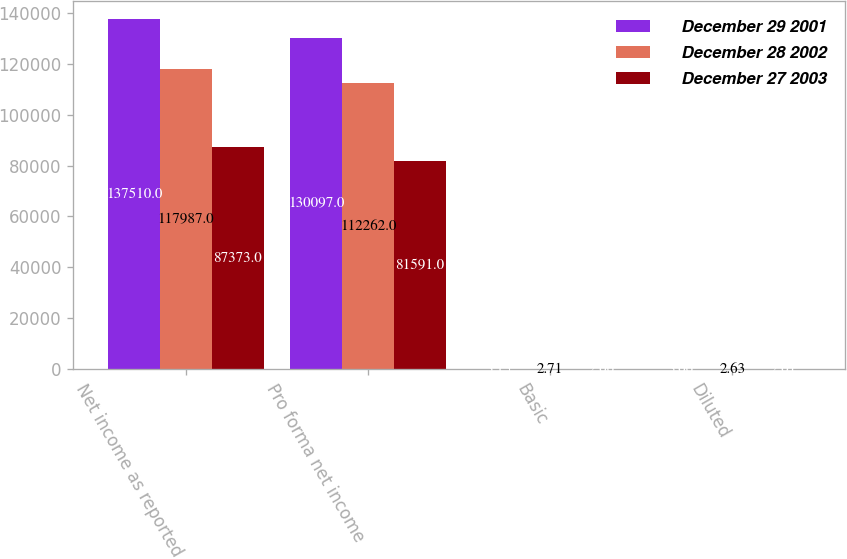Convert chart. <chart><loc_0><loc_0><loc_500><loc_500><stacked_bar_chart><ecel><fcel>Net income as reported<fcel>Pro forma net income<fcel>Basic<fcel>Diluted<nl><fcel>December 29 2001<fcel>137510<fcel>130097<fcel>3.15<fcel>3.06<nl><fcel>December 28 2002<fcel>117987<fcel>112262<fcel>2.71<fcel>2.63<nl><fcel>December 27 2003<fcel>87373<fcel>81591<fcel>2.06<fcel>2.01<nl></chart> 